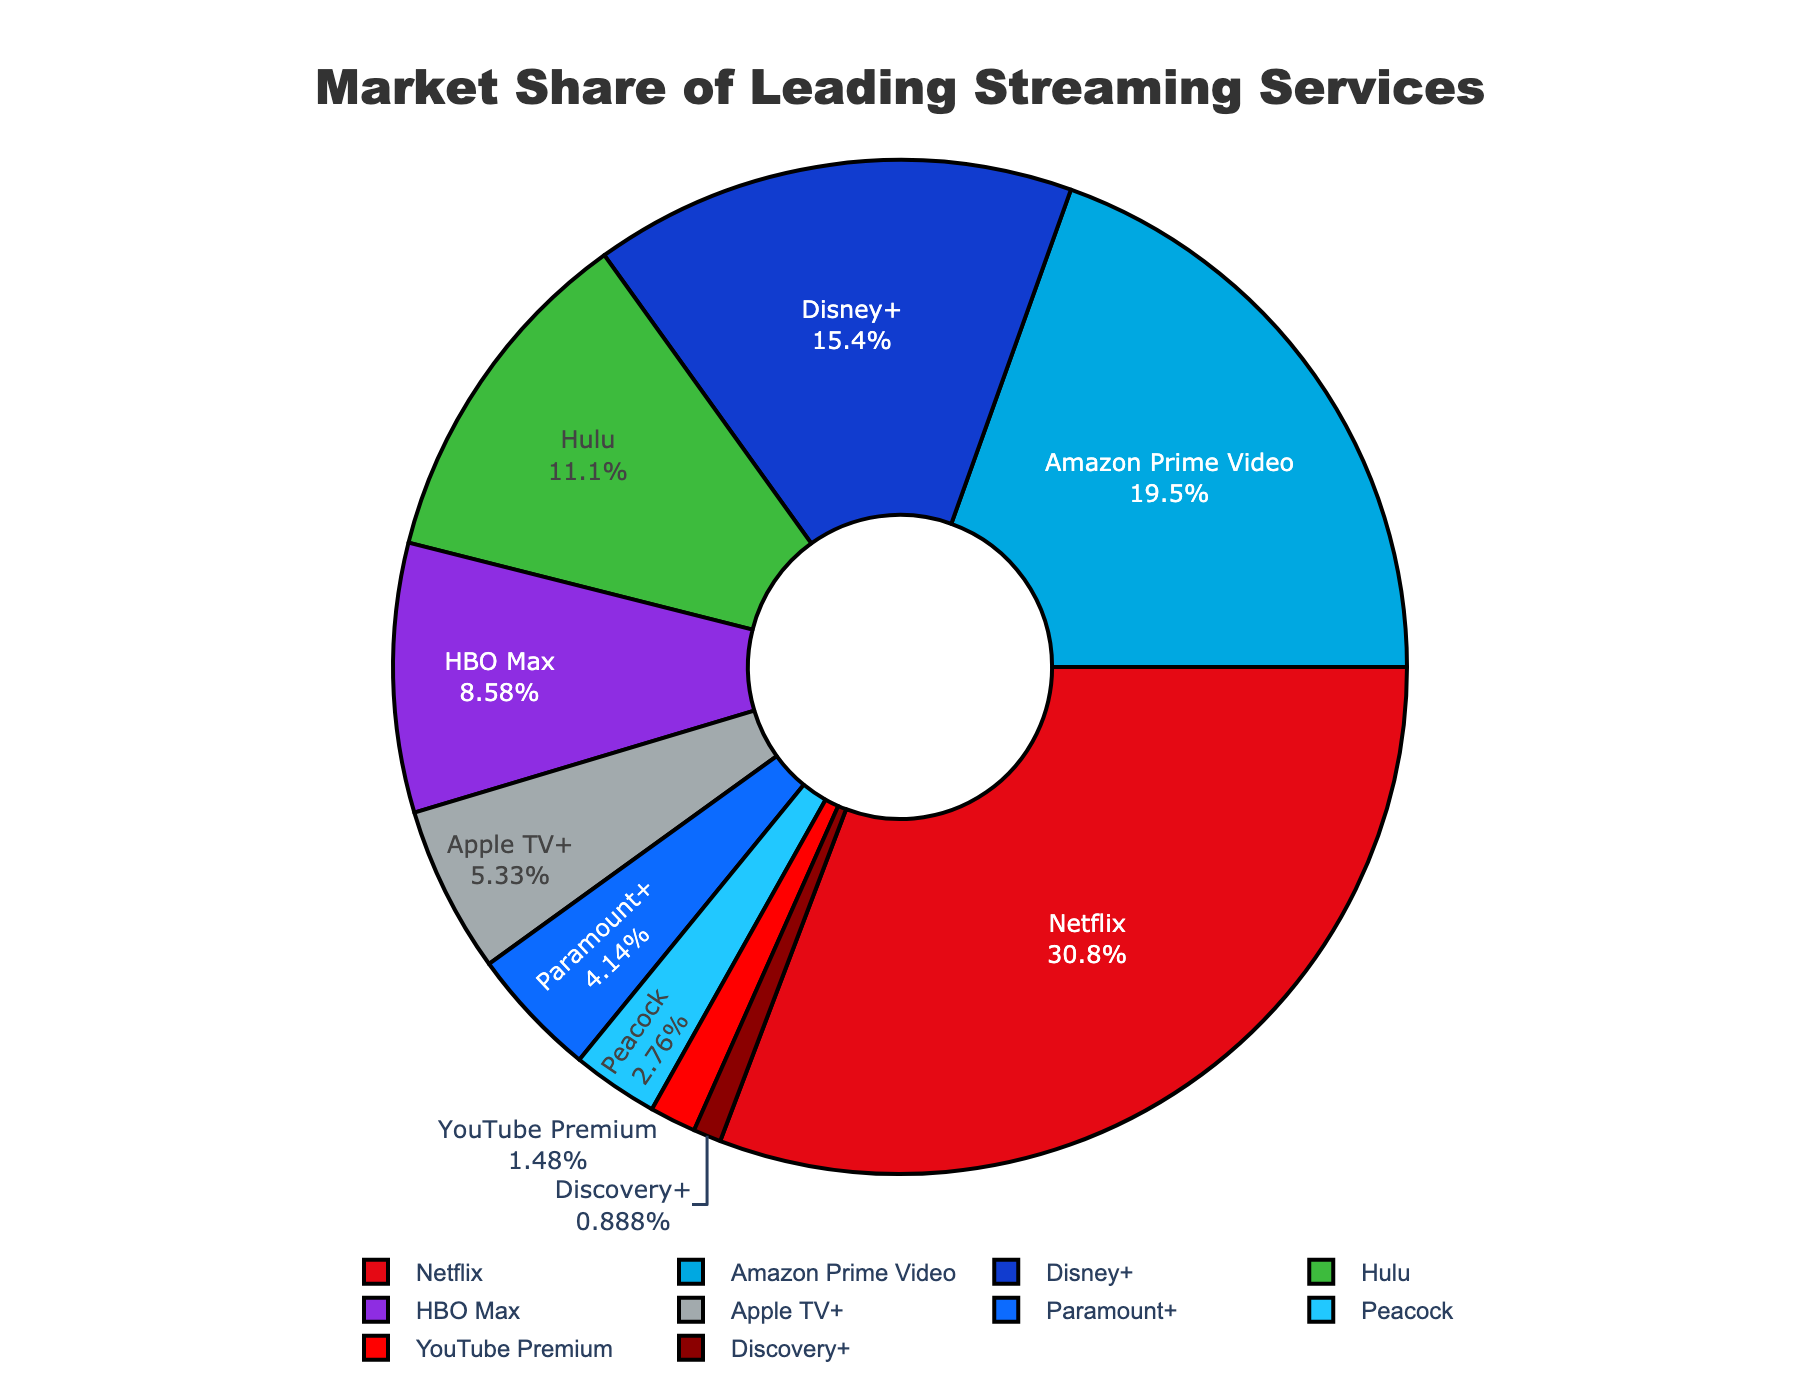What is the market share of the top three streaming services combined? To find the combined market share of the top three services, sum up their individual market shares. Netflix has 31.2%, Amazon Prime Video has 19.8%, and Disney+ has 15.6%. So, 31.2 + 19.8 + 15.6 = 66.6%.
Answer: 66.6% Which streaming service has the smallest market share, and what is its percentage? The figure shows multiple slices of the pie chart, each labeled with the streaming service and its market share. The smallest slice is for Discovery+, which has a market share of 0.9%.
Answer: Discovery+, 0.9% How much larger is Netflix's market share compared to HBO Max's market share? Netflix's market share is 31.2%, and HBO Max's market share is 8.7%. Subtract HBO Max's market share from Netflix's market share to get the difference: 31.2 - 8.7 = 22.5%.
Answer: 22.5% What is the difference in the combined market share between Disney+ and Hulu? Disney+ has a market share of 15.6%, and Hulu has a market share of 11.3%. Subtract Hulu's market share from Disney+'s market share to find the difference: 15.6 - 11.3 = 4.3%.
Answer: 4.3% Which streaming service has a greater market share: Apple TV+ or Paramount+? The pie chart shows Apple TV+ with a market share of 5.4% and Paramount+ with a market share of 4.2%. Apple TV+ has a greater market share.
Answer: Apple TV+ Is the market share of YouTube Premium more or less than 2%? From the figure, YouTube Premium has a market share of 1.5%, which is less than 2%.
Answer: Less What is the average market share of the streaming services that have more than 10% share? The services with more than 10% market share are Netflix (31.2%), Amazon Prime Video (19.8%), Disney+ (15.6%), and Hulu (11.3%). Sum these shares and divide by the number of services: (31.2 + 19.8 + 15.6 + 11.3) / 4 = 77.9 / 4 = 19.475%.
Answer: 19.475% What color is the section for the Peacock streaming service? Visually, the section for Peacock is represented by a dark blue color.
Answer: Dark blue Which streaming service between Amazon Prime Video and Disney+ has a higher market share, and by how much? Amazon Prime Video has a market share of 19.8%, and Disney+ has a share of 15.6%. The difference is 19.8 - 15.6 = 4.2%. Amazon Prime Video has a higher market share by 4.2%.
Answer: Amazon Prime Video, 4.2% 